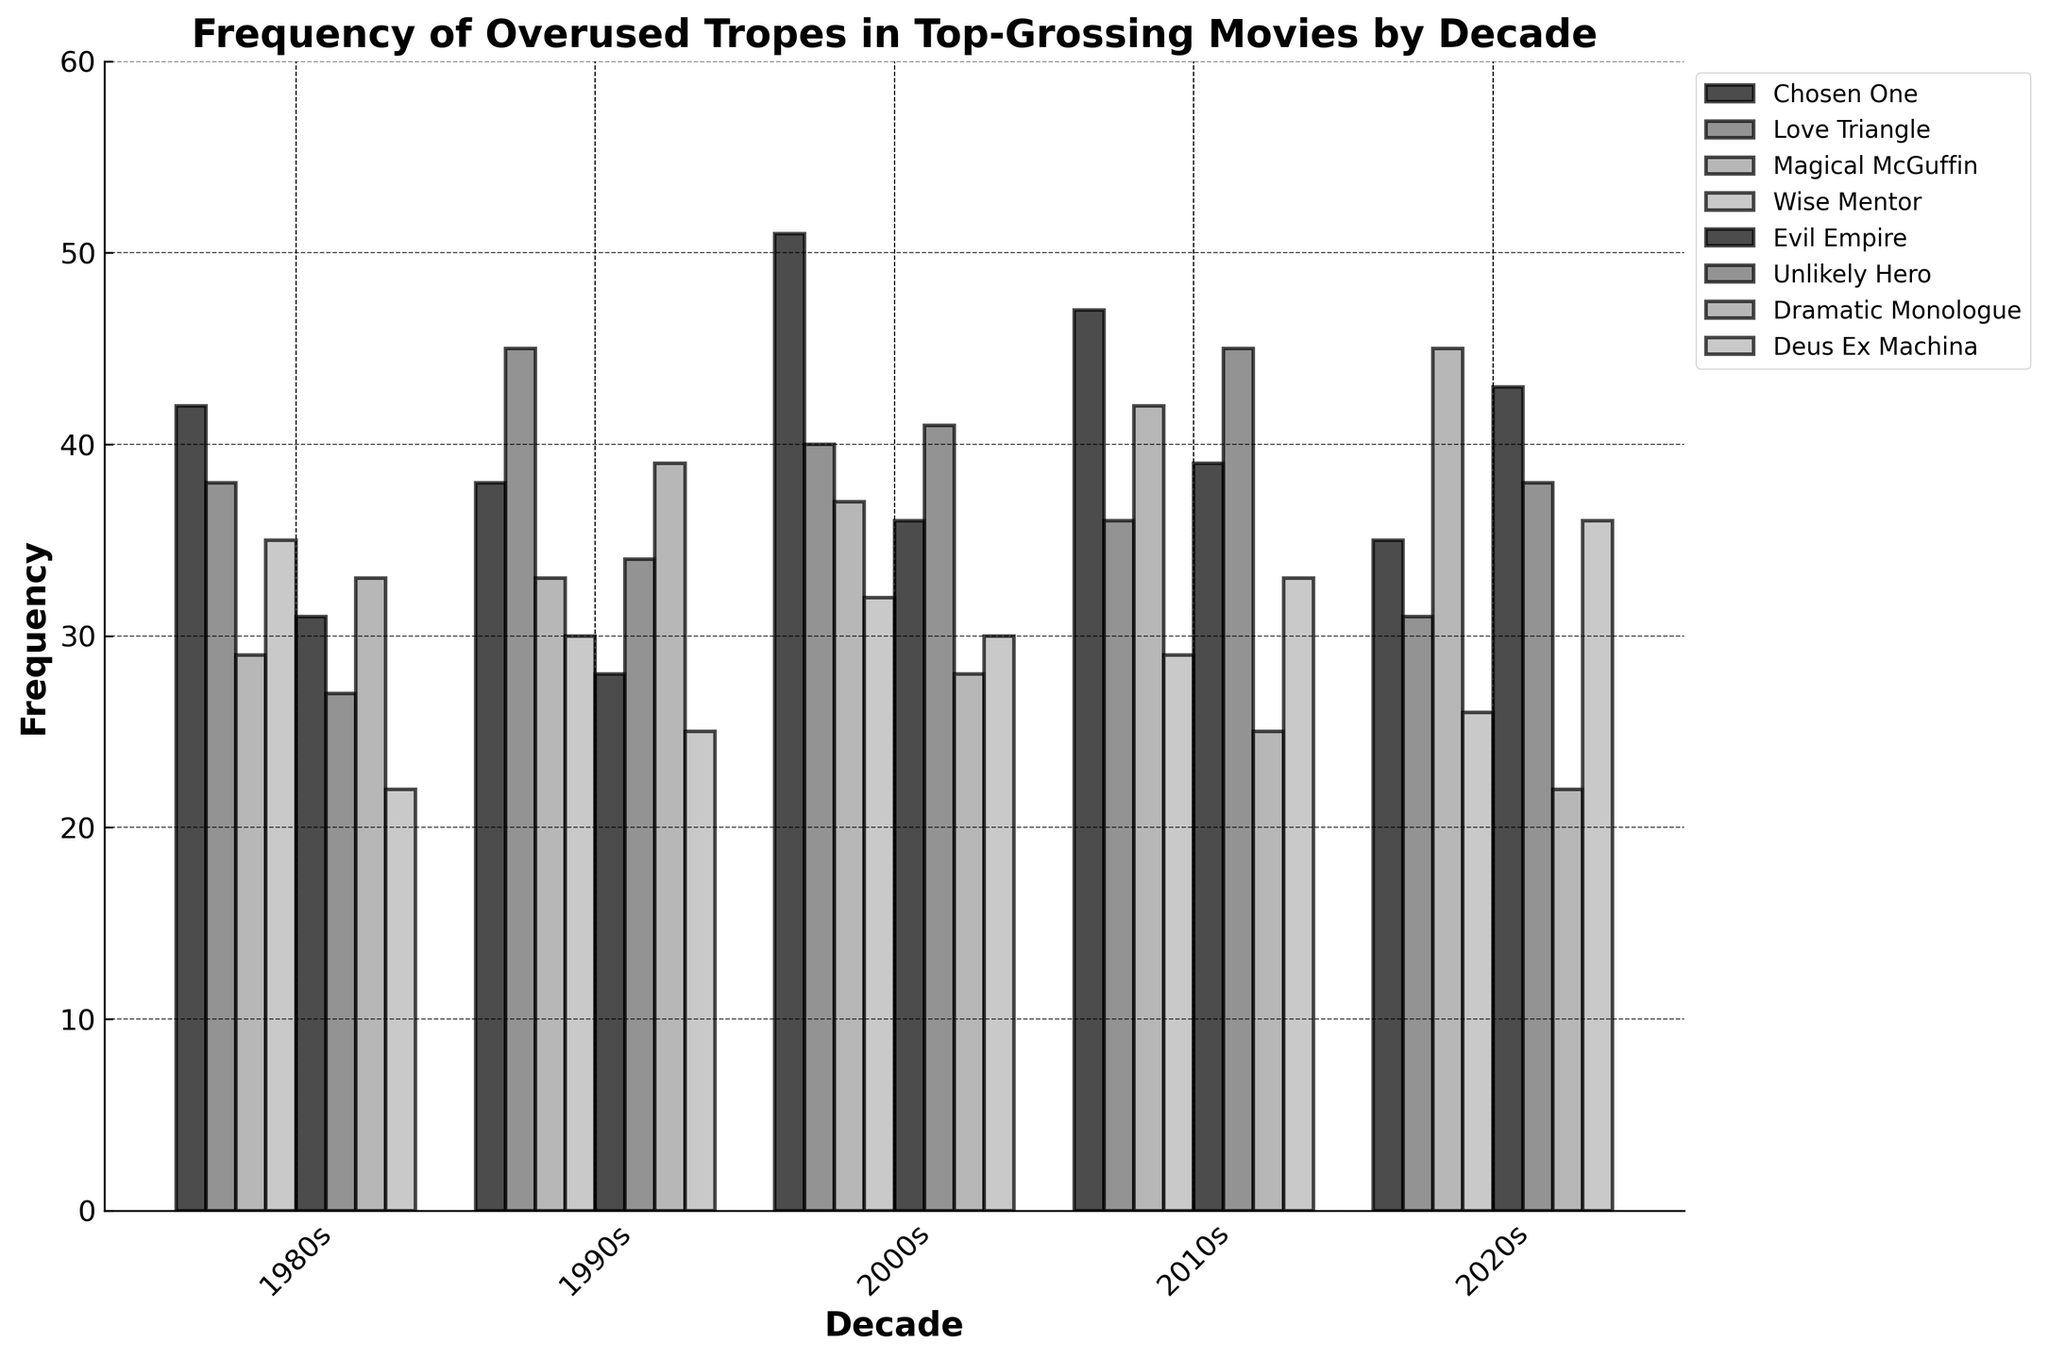Which trope was most frequent in the 2000s? Look at the bars representing the 2000s and identify the highest one. The tallest bar shows the 'Chosen One' trope.
Answer: Chosen One How does the frequency of 'Love Triangle' in the 1990s compare to the 2020s? Compare the height of the 'Love Triangle' bars for the 1990s and 2020s. The 1990s bar is taller than the 2020s bar.
Answer: Higher in the 1990s What is the average frequency of 'Evil Empire' across all decades? Sum the frequencies of 'Evil Empire' across all decades and divide by the number of decades: (31 + 28 + 36 + 39 + 43) / 5 = 35.4
Answer: 35.4 Which decade had the lowest frequency of 'Unlikely Hero'? Look at the bars representing 'Unlikely Hero' across all decades and identify the shortest one. The shortest bar is in the 1980s.
Answer: 1980s How did the frequency of 'Dramatic Monologue' change from the 1990s to the 2010s? Subtract the 'Dramatic Monologue' frequency in the 1990s from that in the 2010s: 25 - 39 = -14. The frequency decreased by 14.
Answer: Decreased by 14 What is the sum of the frequencies of 'Magical McGuffin' and 'Wise Mentor' in the 2010s? Add the 'Magical McGuffin' and 'Wise Mentor' values for the 2010s: 42 + 29 = 71.
Answer: 71 Which trope's frequency remained relatively stable across all decades? Examine the bars for each trope across all decades and identify the one with the least variation. The 'Wise Mentor' shows relatively small changes.
Answer: Wise Mentor Which decade had the highest total frequency of all tropes combined? Sum the frequencies of all tropes for each decade and compare them. The highest sum is in the 2000s: (51 + 40 + 37 + 32 + 36 + 41 + 28 + 30) = 295.
Answer: 2000s How does the frequency of 'Deus Ex Machina' in the 2020s compare to the 1980s? Compare the bars of 'Deus Ex Machina' for the 2020s and the 1980s. The 2020s bar is taller than the 1980s bar.
Answer: Higher in the 2020s 